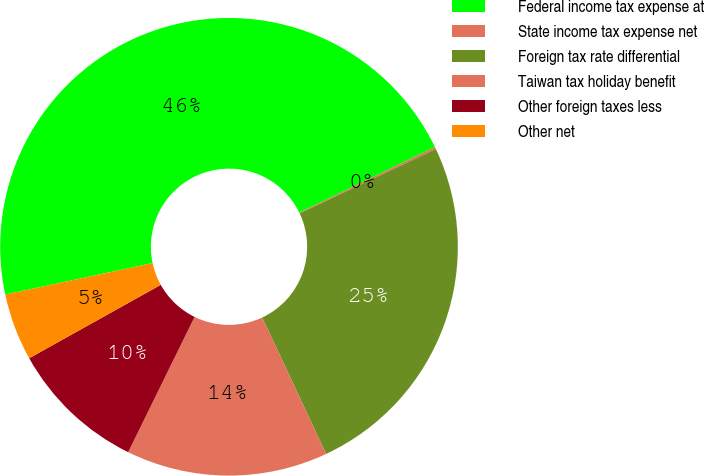Convert chart. <chart><loc_0><loc_0><loc_500><loc_500><pie_chart><fcel>Federal income tax expense at<fcel>State income tax expense net<fcel>Foreign tax rate differential<fcel>Taiwan tax holiday benefit<fcel>Other foreign taxes less<fcel>Other net<nl><fcel>46.17%<fcel>0.15%<fcel>25.05%<fcel>14.24%<fcel>9.64%<fcel>4.75%<nl></chart> 